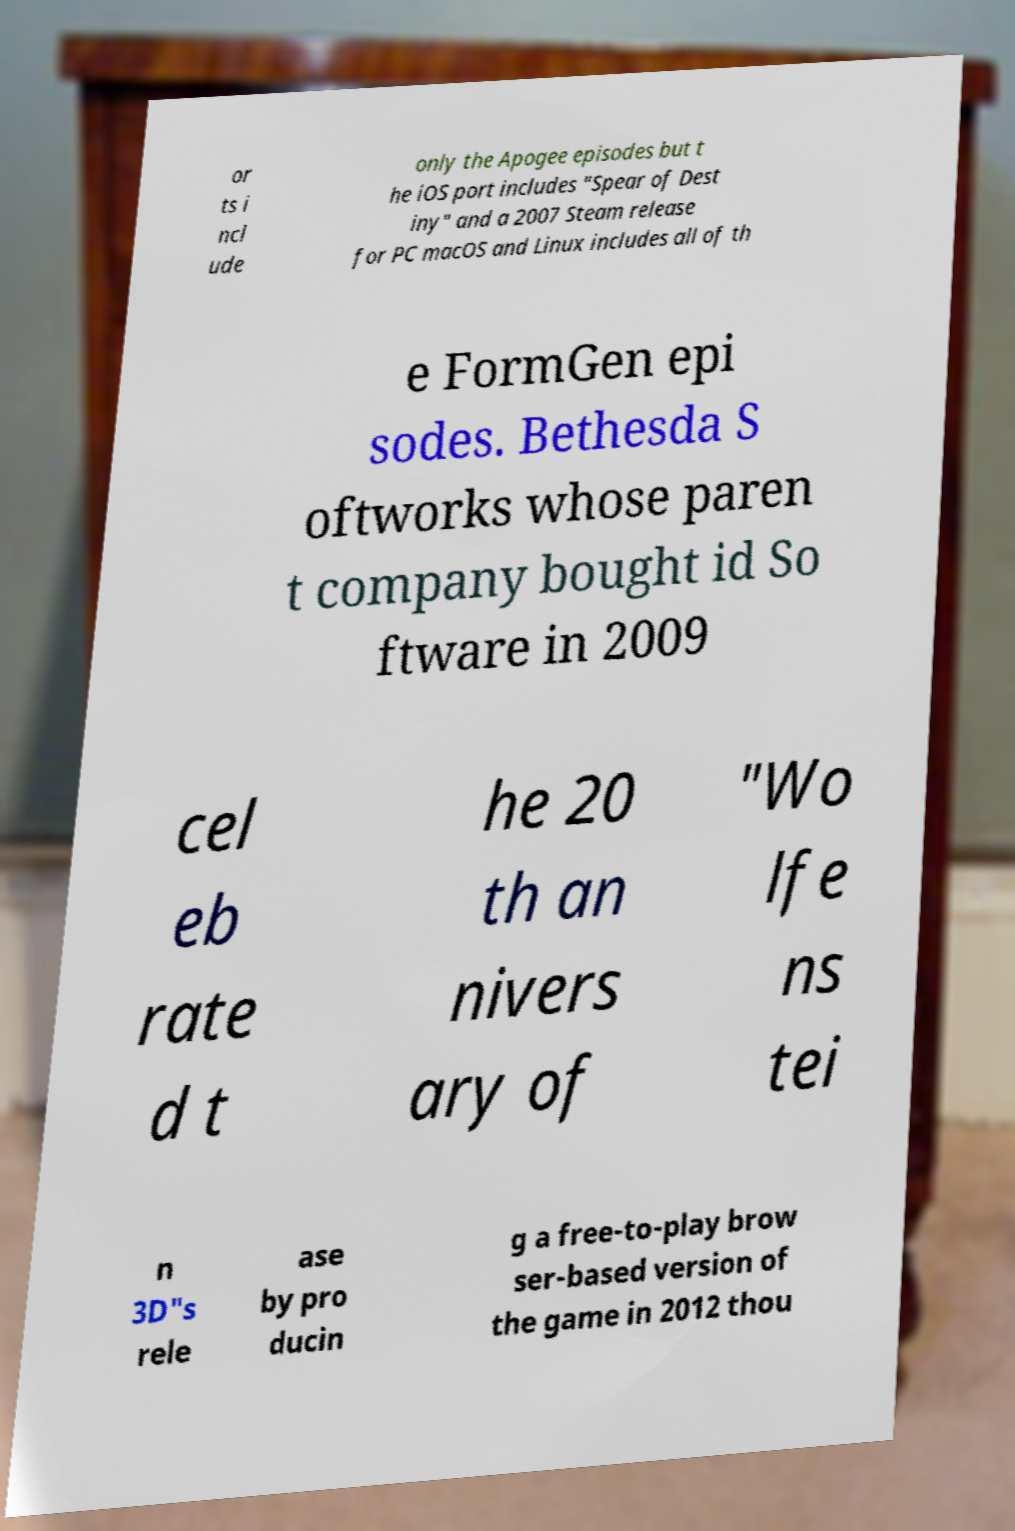Could you extract and type out the text from this image? or ts i ncl ude only the Apogee episodes but t he iOS port includes "Spear of Dest iny" and a 2007 Steam release for PC macOS and Linux includes all of th e FormGen epi sodes. Bethesda S oftworks whose paren t company bought id So ftware in 2009 cel eb rate d t he 20 th an nivers ary of "Wo lfe ns tei n 3D"s rele ase by pro ducin g a free-to-play brow ser-based version of the game in 2012 thou 